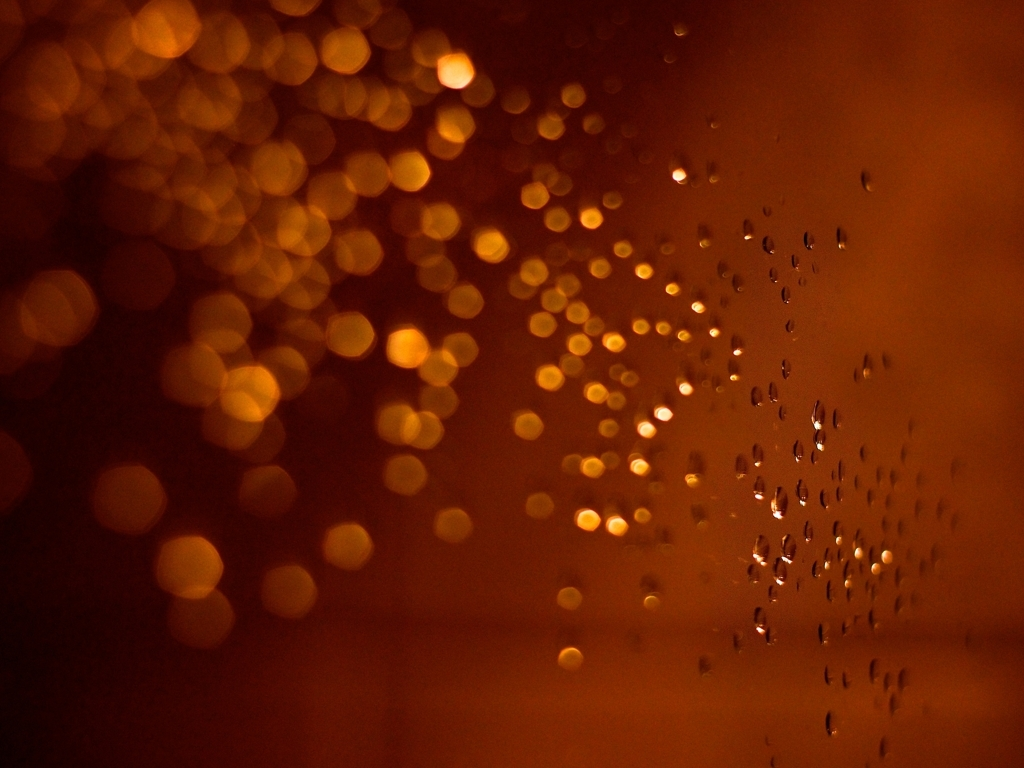Are there any artifacts present in the image? Yes, the image does display artifacts in the form of water droplets on what appears to be a transparent surface, possibly glass, with a bokeh effect from lights in the background creating an aesthetically pleasing visual texture. 